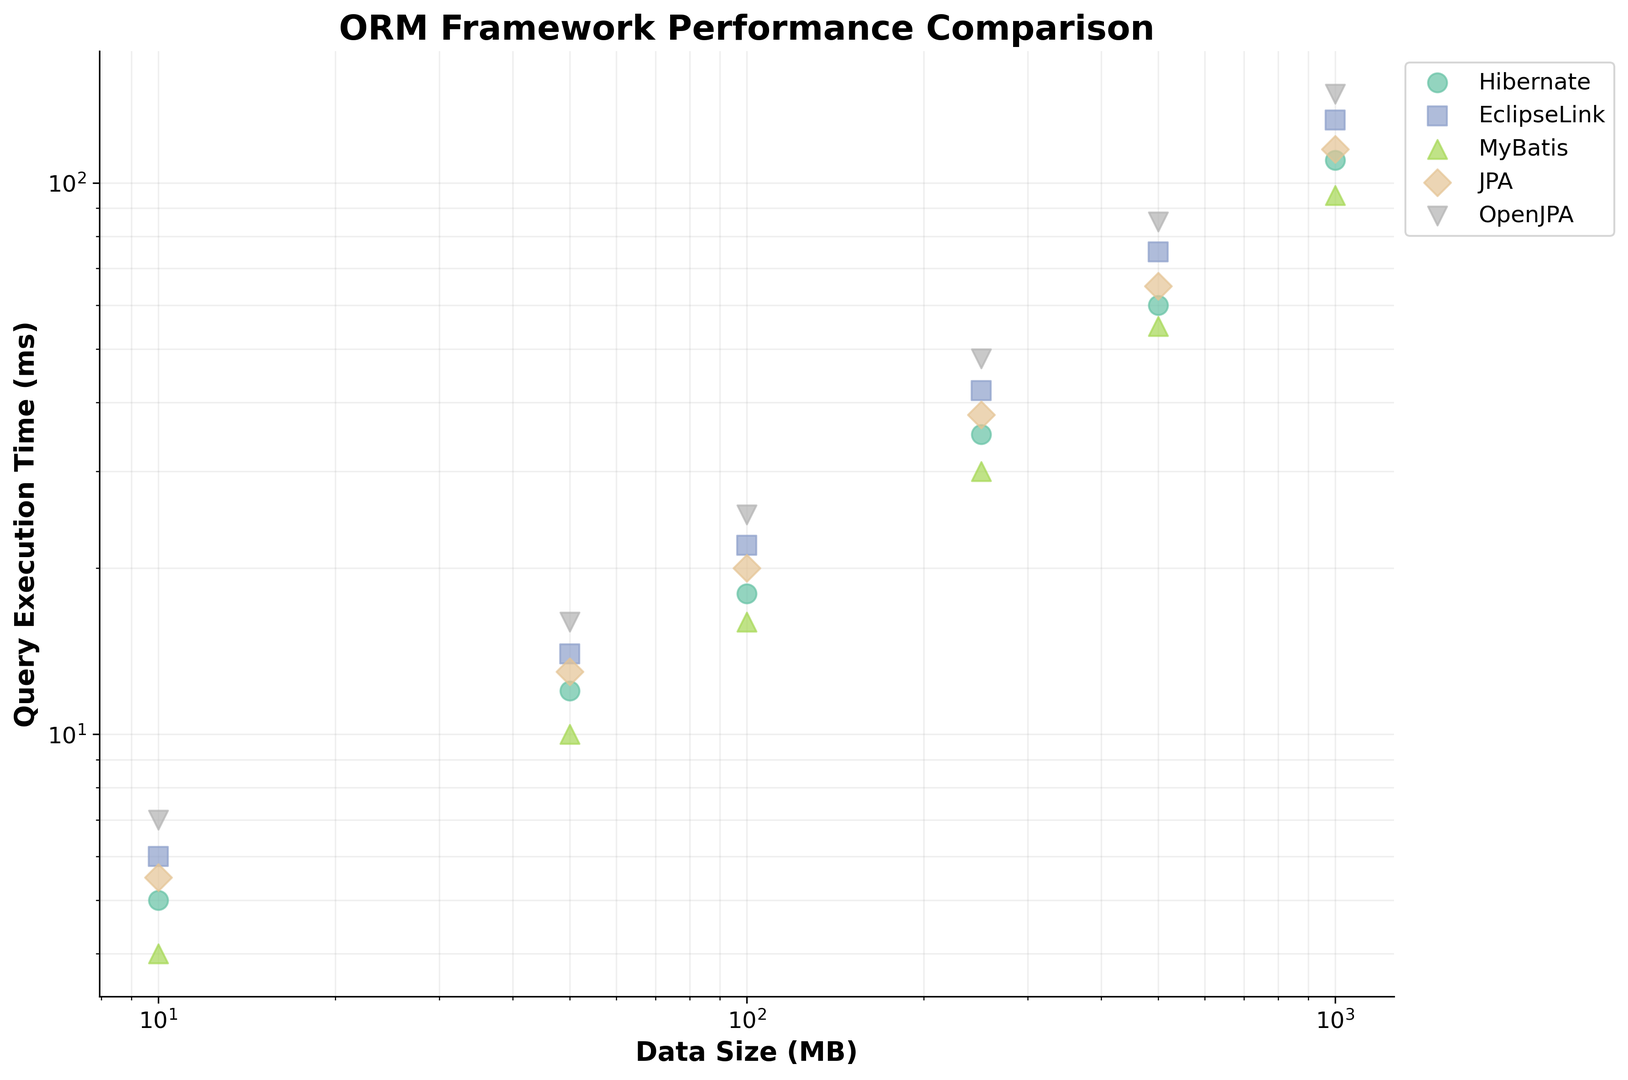Which ORM framework has the lowest query execution time for a data size of 100 MB? To determine this, we look at the data points for each framework at 100 MB on the x-axis and compare their respective execution time values on the y-axis. MyBatis shows the lowest position on the y-axis for this data size.
Answer: MyBatis How does the execution time of JPA compare to OpenJPA at 500 MB? Locate both JPA and OpenJPA data points aligned with 500 MB on the x-axis. JPA's execution time is 65 ms, whereas OpenJPA's execution time is 85 ms, making JPA's execution time shorter by 20 ms.
Answer: JPA is 20 ms faster Which framework has the steepest increase in query execution time as data size increases? The steepest increase is identified by the slope of the trend for each framework. OpenJPA's line increases the most rapidly on the y-axis as the data size increases, which is visually steepest.
Answer: OpenJPA Compare the average execution times of Hibernate and EclipseLink across all data sizes. Calculate the average execution time for each framework by summing their execution times and dividing by the number of data points. Hibernate: (5+12+18+35+60+110)/6 = 40 ms; EclipseLink: (6+14+22+42+75+130)/6 = 48.2 ms.
Answer: Hibernate is faster on average by 8.2 ms What is the difference in query execution time between MyBatis and Hibernate at 1000 MB? Compare the execution times for MyBatis (95 ms) and Hibernate (110 ms) data points at 1000 MB on the x-axis. The difference is 110 - 95 = 15 ms.
Answer: 15 ms At what data size does EclipseLink exceed 20 ms in query execution time? Find the point on the x-axis where EclipseLink's data points first go above 20 ms on the y-axis. EclipseLink exceeds 20 ms at a data size of 100 MB.
Answer: 100 MB Which framework remains under 50 ms execution time the longest as data size increases? Check each framework's data points to see up to which data size they stay under 50 ms on the y-axis. MyBatis remains under 50 ms execution time up to 250 MB.
Answer: MyBatis For a data size of 250 MB, what is the combined execution time for JPA and OpenJPA? Look at the execution times at 250 MB for JPA (38 ms) and OpenJPA (48 ms), then sum them up: 38 + 48 = 86 ms.
Answer: 86 ms Which framework shows the smallest increase in query execution time from 10 MB to 50 MB? Calculate the differences for each framework between 10 MB and 50 MB. Hibernate: 12 - 5 = 7 ms; EclipseLink: 14 - 6 = 8 ms; MyBatis: 10 - 4 = 6 ms; JPA: 13 - 5.5 = 7.5 ms; OpenJPA: 16 - 7 = 9 ms. The smallest increase is for MyBatis.
Answer: MyBatis How does the performance of Hibernate compare across the two smallest data sizes, 10 MB and 50 MB? Compare the execution times for Hibernate at 10 MB (5 ms) and at 50 MB (12 ms). The difference is 12 - 5 = 7 ms, indicating a performance increase.
Answer: Time increased by 7 ms 